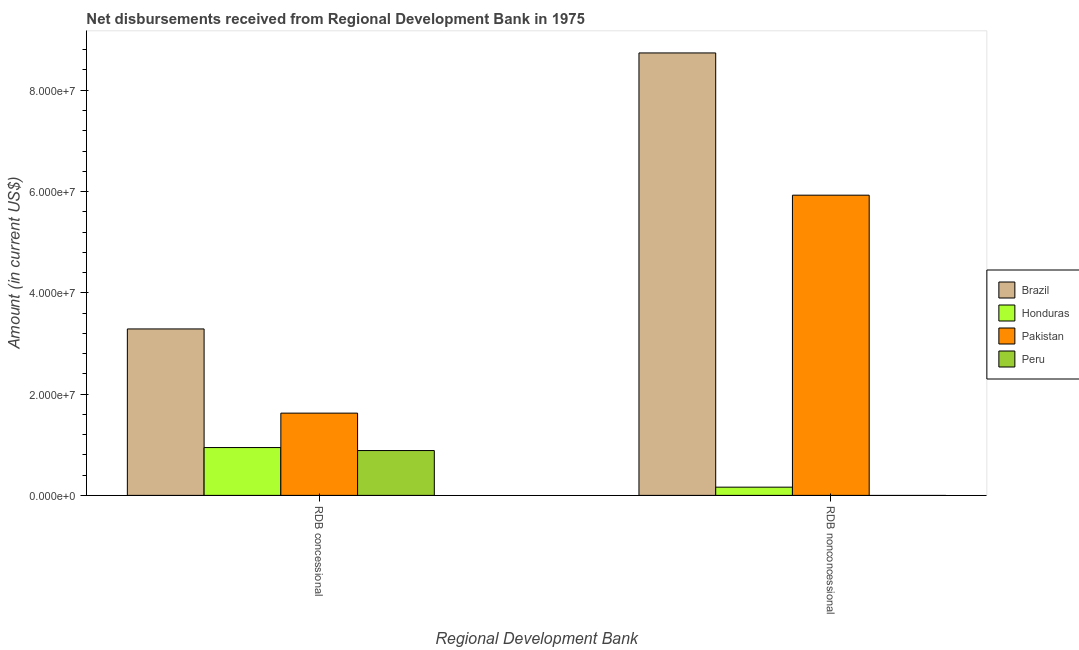How many different coloured bars are there?
Offer a terse response. 4. How many groups of bars are there?
Offer a very short reply. 2. How many bars are there on the 2nd tick from the left?
Ensure brevity in your answer.  3. What is the label of the 2nd group of bars from the left?
Offer a terse response. RDB nonconcessional. What is the net non concessional disbursements from rdb in Honduras?
Offer a very short reply. 1.62e+06. Across all countries, what is the maximum net non concessional disbursements from rdb?
Make the answer very short. 8.74e+07. Across all countries, what is the minimum net concessional disbursements from rdb?
Keep it short and to the point. 8.85e+06. What is the total net concessional disbursements from rdb in the graph?
Provide a short and direct response. 6.74e+07. What is the difference between the net concessional disbursements from rdb in Peru and that in Honduras?
Offer a terse response. -5.95e+05. What is the difference between the net non concessional disbursements from rdb in Honduras and the net concessional disbursements from rdb in Peru?
Make the answer very short. -7.23e+06. What is the average net non concessional disbursements from rdb per country?
Your answer should be compact. 3.71e+07. What is the difference between the net concessional disbursements from rdb and net non concessional disbursements from rdb in Pakistan?
Provide a short and direct response. -4.30e+07. In how many countries, is the net non concessional disbursements from rdb greater than 84000000 US$?
Your response must be concise. 1. What is the ratio of the net concessional disbursements from rdb in Honduras to that in Brazil?
Your answer should be compact. 0.29. Is the net non concessional disbursements from rdb in Honduras less than that in Brazil?
Your answer should be compact. Yes. How many bars are there?
Make the answer very short. 7. Are all the bars in the graph horizontal?
Give a very brief answer. No. Does the graph contain grids?
Your answer should be compact. No. Where does the legend appear in the graph?
Your response must be concise. Center right. How many legend labels are there?
Give a very brief answer. 4. What is the title of the graph?
Your answer should be very brief. Net disbursements received from Regional Development Bank in 1975. What is the label or title of the X-axis?
Your answer should be compact. Regional Development Bank. What is the label or title of the Y-axis?
Make the answer very short. Amount (in current US$). What is the Amount (in current US$) of Brazil in RDB concessional?
Offer a very short reply. 3.29e+07. What is the Amount (in current US$) in Honduras in RDB concessional?
Ensure brevity in your answer.  9.45e+06. What is the Amount (in current US$) in Pakistan in RDB concessional?
Your answer should be compact. 1.62e+07. What is the Amount (in current US$) in Peru in RDB concessional?
Ensure brevity in your answer.  8.85e+06. What is the Amount (in current US$) of Brazil in RDB nonconcessional?
Offer a terse response. 8.74e+07. What is the Amount (in current US$) of Honduras in RDB nonconcessional?
Make the answer very short. 1.62e+06. What is the Amount (in current US$) of Pakistan in RDB nonconcessional?
Your answer should be very brief. 5.93e+07. What is the Amount (in current US$) of Peru in RDB nonconcessional?
Make the answer very short. 0. Across all Regional Development Bank, what is the maximum Amount (in current US$) of Brazil?
Your answer should be compact. 8.74e+07. Across all Regional Development Bank, what is the maximum Amount (in current US$) in Honduras?
Your answer should be very brief. 9.45e+06. Across all Regional Development Bank, what is the maximum Amount (in current US$) in Pakistan?
Offer a terse response. 5.93e+07. Across all Regional Development Bank, what is the maximum Amount (in current US$) in Peru?
Keep it short and to the point. 8.85e+06. Across all Regional Development Bank, what is the minimum Amount (in current US$) of Brazil?
Give a very brief answer. 3.29e+07. Across all Regional Development Bank, what is the minimum Amount (in current US$) of Honduras?
Keep it short and to the point. 1.62e+06. Across all Regional Development Bank, what is the minimum Amount (in current US$) in Pakistan?
Provide a short and direct response. 1.62e+07. Across all Regional Development Bank, what is the minimum Amount (in current US$) of Peru?
Offer a terse response. 0. What is the total Amount (in current US$) of Brazil in the graph?
Make the answer very short. 1.20e+08. What is the total Amount (in current US$) in Honduras in the graph?
Your answer should be very brief. 1.11e+07. What is the total Amount (in current US$) in Pakistan in the graph?
Your answer should be compact. 7.55e+07. What is the total Amount (in current US$) in Peru in the graph?
Your response must be concise. 8.85e+06. What is the difference between the Amount (in current US$) in Brazil in RDB concessional and that in RDB nonconcessional?
Offer a very short reply. -5.45e+07. What is the difference between the Amount (in current US$) in Honduras in RDB concessional and that in RDB nonconcessional?
Your response must be concise. 7.82e+06. What is the difference between the Amount (in current US$) in Pakistan in RDB concessional and that in RDB nonconcessional?
Offer a very short reply. -4.30e+07. What is the difference between the Amount (in current US$) of Brazil in RDB concessional and the Amount (in current US$) of Honduras in RDB nonconcessional?
Keep it short and to the point. 3.12e+07. What is the difference between the Amount (in current US$) of Brazil in RDB concessional and the Amount (in current US$) of Pakistan in RDB nonconcessional?
Provide a short and direct response. -2.64e+07. What is the difference between the Amount (in current US$) in Honduras in RDB concessional and the Amount (in current US$) in Pakistan in RDB nonconcessional?
Make the answer very short. -4.98e+07. What is the average Amount (in current US$) in Brazil per Regional Development Bank?
Ensure brevity in your answer.  6.01e+07. What is the average Amount (in current US$) in Honduras per Regional Development Bank?
Your response must be concise. 5.53e+06. What is the average Amount (in current US$) of Pakistan per Regional Development Bank?
Ensure brevity in your answer.  3.78e+07. What is the average Amount (in current US$) of Peru per Regional Development Bank?
Offer a terse response. 4.43e+06. What is the difference between the Amount (in current US$) of Brazil and Amount (in current US$) of Honduras in RDB concessional?
Provide a short and direct response. 2.34e+07. What is the difference between the Amount (in current US$) of Brazil and Amount (in current US$) of Pakistan in RDB concessional?
Your response must be concise. 1.66e+07. What is the difference between the Amount (in current US$) of Brazil and Amount (in current US$) of Peru in RDB concessional?
Offer a terse response. 2.40e+07. What is the difference between the Amount (in current US$) in Honduras and Amount (in current US$) in Pakistan in RDB concessional?
Offer a very short reply. -6.80e+06. What is the difference between the Amount (in current US$) of Honduras and Amount (in current US$) of Peru in RDB concessional?
Provide a short and direct response. 5.95e+05. What is the difference between the Amount (in current US$) of Pakistan and Amount (in current US$) of Peru in RDB concessional?
Your answer should be very brief. 7.39e+06. What is the difference between the Amount (in current US$) of Brazil and Amount (in current US$) of Honduras in RDB nonconcessional?
Provide a succinct answer. 8.57e+07. What is the difference between the Amount (in current US$) in Brazil and Amount (in current US$) in Pakistan in RDB nonconcessional?
Your answer should be compact. 2.81e+07. What is the difference between the Amount (in current US$) of Honduras and Amount (in current US$) of Pakistan in RDB nonconcessional?
Your response must be concise. -5.77e+07. What is the ratio of the Amount (in current US$) in Brazil in RDB concessional to that in RDB nonconcessional?
Give a very brief answer. 0.38. What is the ratio of the Amount (in current US$) of Honduras in RDB concessional to that in RDB nonconcessional?
Make the answer very short. 5.82. What is the ratio of the Amount (in current US$) in Pakistan in RDB concessional to that in RDB nonconcessional?
Your response must be concise. 0.27. What is the difference between the highest and the second highest Amount (in current US$) of Brazil?
Ensure brevity in your answer.  5.45e+07. What is the difference between the highest and the second highest Amount (in current US$) in Honduras?
Your answer should be compact. 7.82e+06. What is the difference between the highest and the second highest Amount (in current US$) of Pakistan?
Your answer should be very brief. 4.30e+07. What is the difference between the highest and the lowest Amount (in current US$) of Brazil?
Provide a short and direct response. 5.45e+07. What is the difference between the highest and the lowest Amount (in current US$) in Honduras?
Ensure brevity in your answer.  7.82e+06. What is the difference between the highest and the lowest Amount (in current US$) in Pakistan?
Your answer should be compact. 4.30e+07. What is the difference between the highest and the lowest Amount (in current US$) in Peru?
Provide a succinct answer. 8.85e+06. 